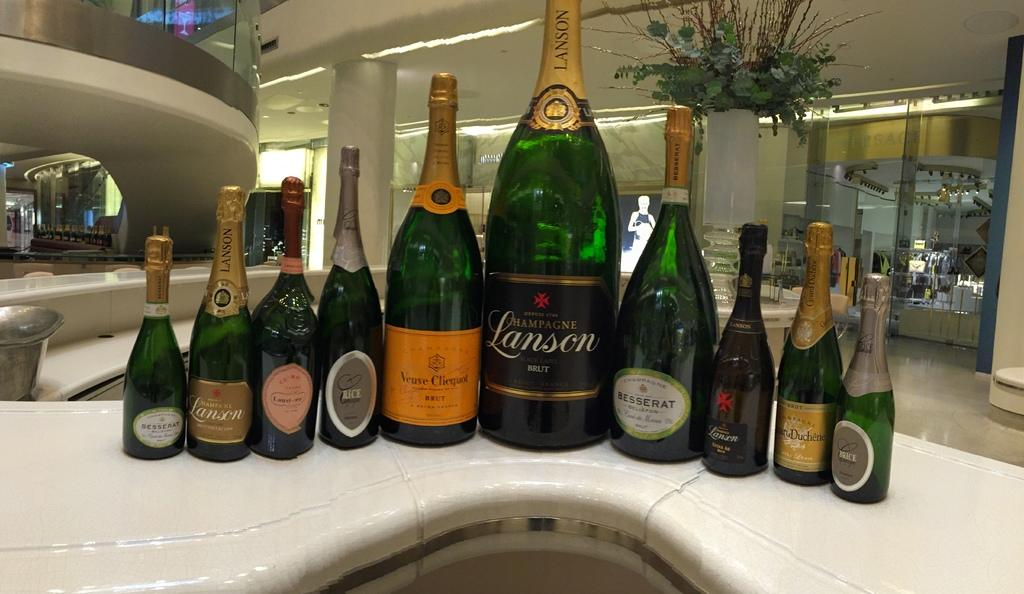<image>
Give a short and clear explanation of the subsequent image. Lansen Champagne, Brice Champagne, and Besserat Champagne on a table. 